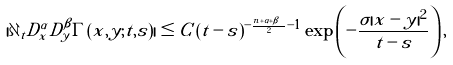<formula> <loc_0><loc_0><loc_500><loc_500>| \partial _ { t } D _ { x } ^ { \alpha } D _ { y } ^ { \beta } \Gamma ( x , y ; t , s ) | \leq C \, ( t - s ) ^ { - \frac { n + | \alpha | + | \beta | } 2 - 1 } \, \exp \left ( - \frac { \sigma | x - y | ^ { 2 } } { t - s } \right ) ,</formula> 